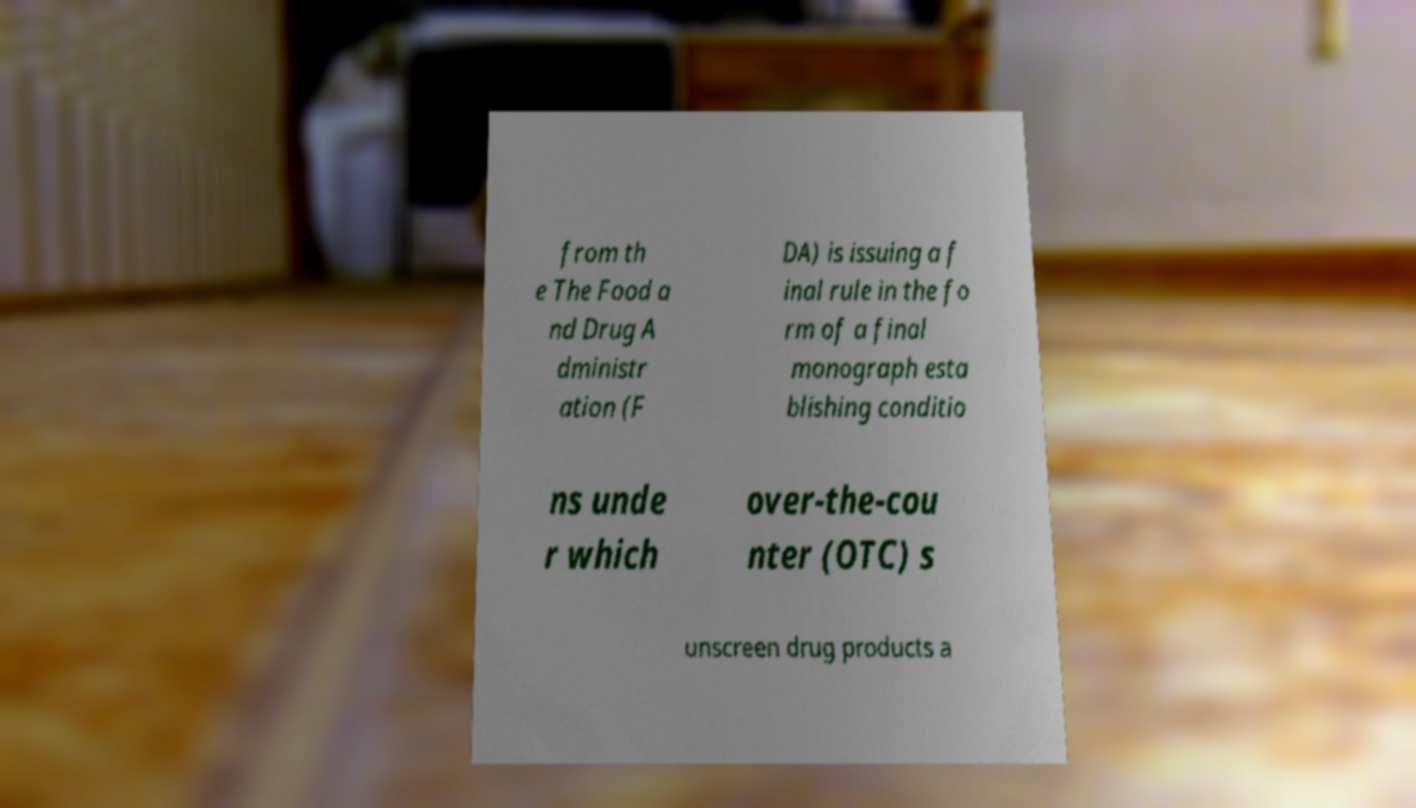For documentation purposes, I need the text within this image transcribed. Could you provide that? from th e The Food a nd Drug A dministr ation (F DA) is issuing a f inal rule in the fo rm of a final monograph esta blishing conditio ns unde r which over-the-cou nter (OTC) s unscreen drug products a 